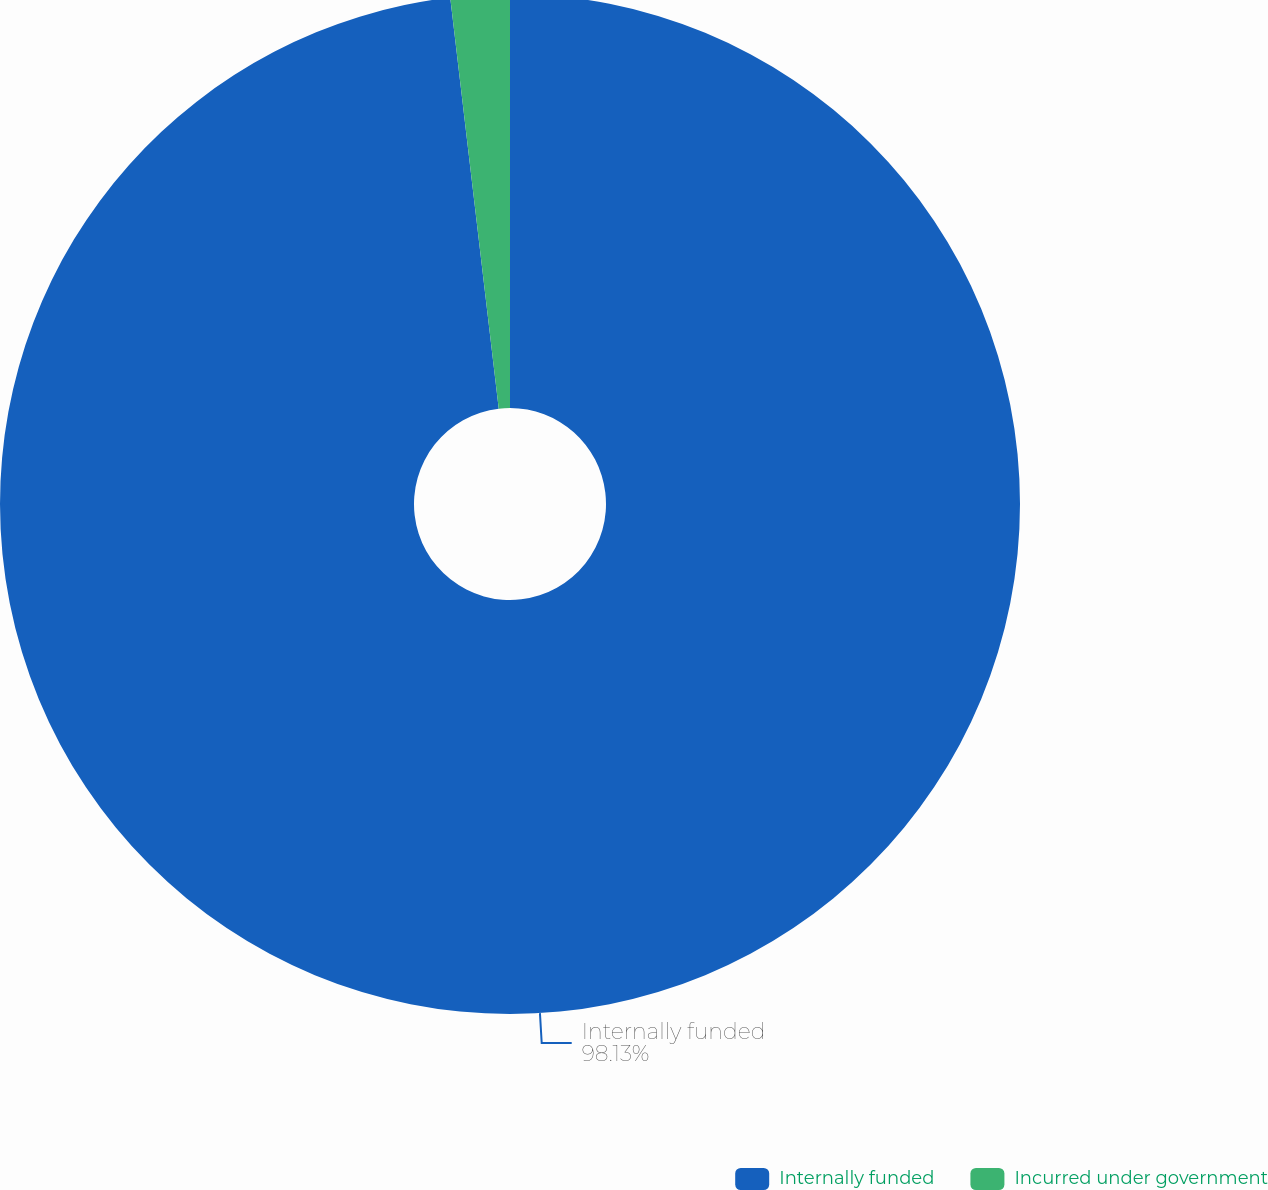<chart> <loc_0><loc_0><loc_500><loc_500><pie_chart><fcel>Internally funded<fcel>Incurred under government<nl><fcel>98.13%<fcel>1.87%<nl></chart> 